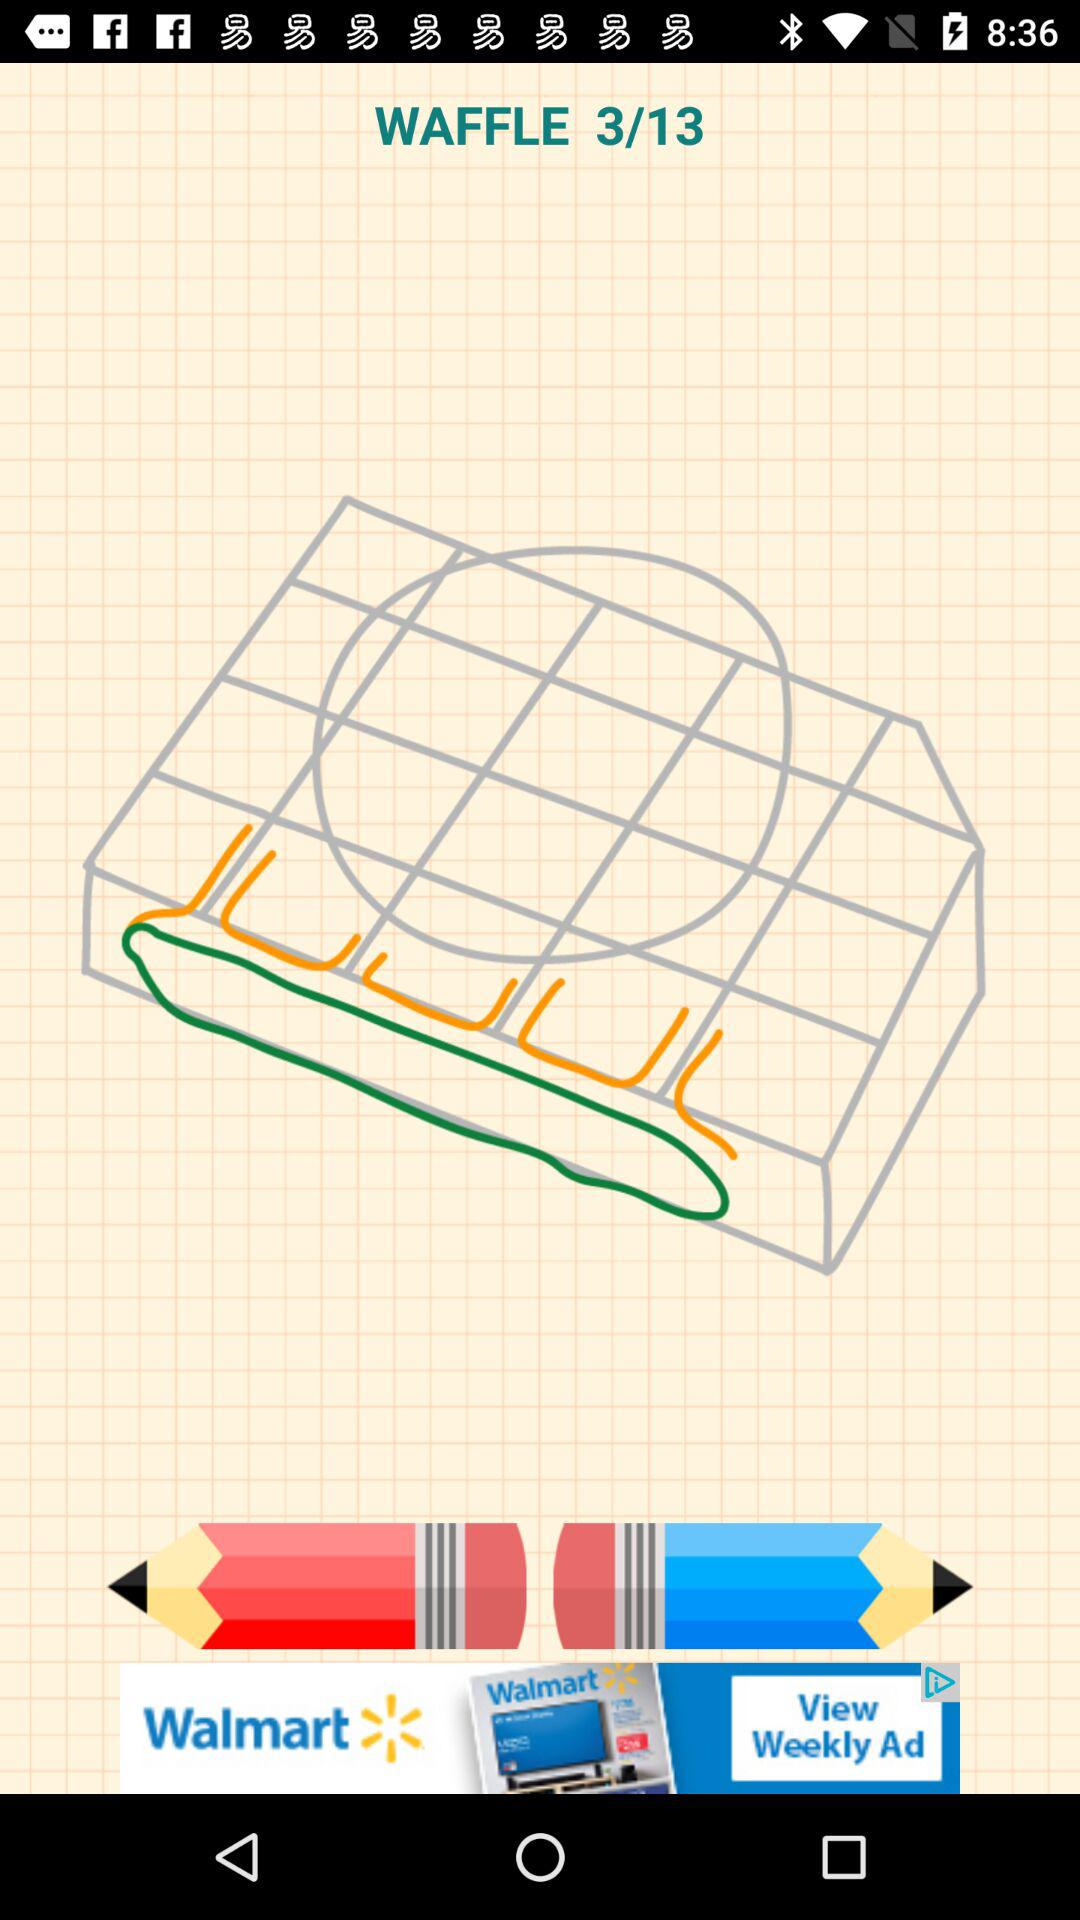What step of the waffle are we on? You are on the 3 step of the waffle. 